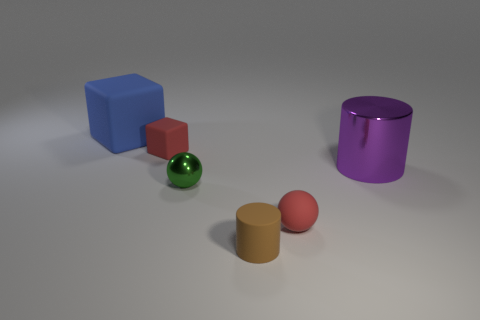Add 4 matte cylinders. How many objects exist? 10 Subtract all cubes. How many objects are left? 4 Subtract all green metal balls. Subtract all big blue objects. How many objects are left? 4 Add 4 small red rubber spheres. How many small red rubber spheres are left? 5 Add 6 small green objects. How many small green objects exist? 7 Subtract 0 brown spheres. How many objects are left? 6 